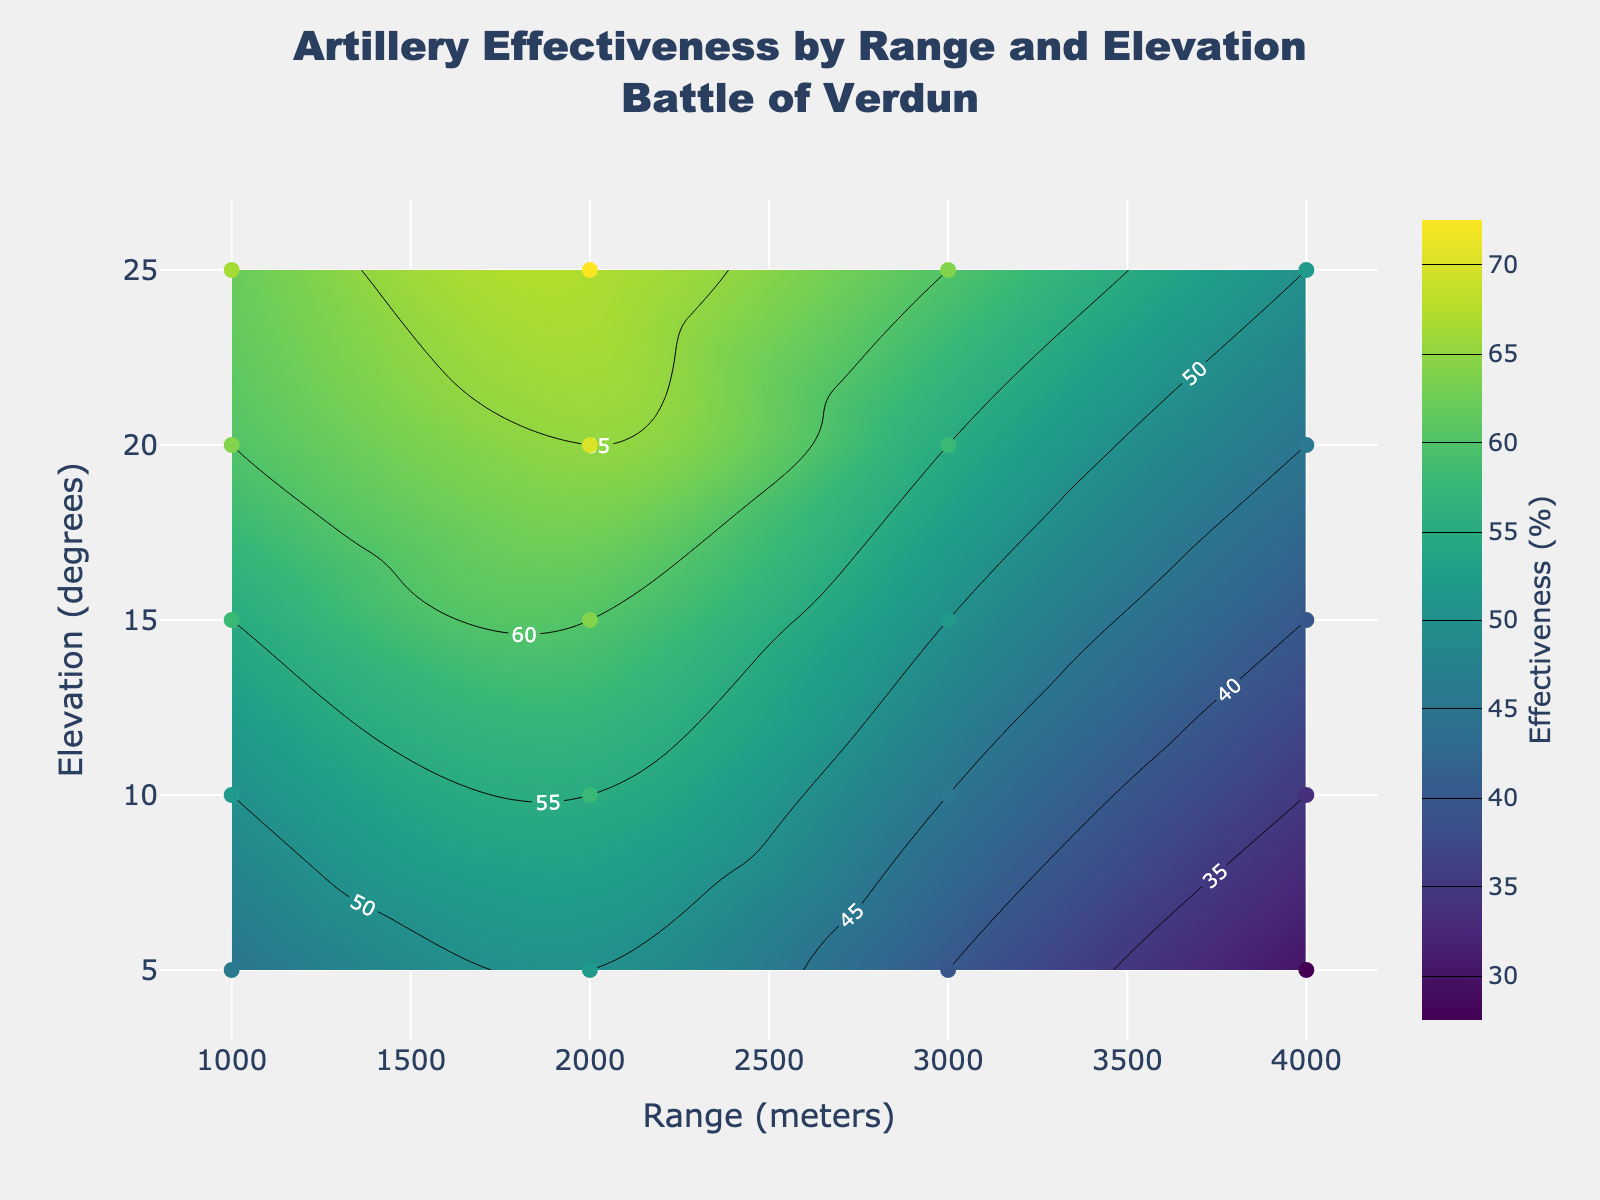What is the title of the plot? The title is displayed at the top of the plot. It reads 'Artillery Effectiveness by Range and Elevation<br>Battle of Verdun'.
Answer: 'Artillery Effectiveness by Range and Elevation<br>Battle of Verdun' What are the ranges of the x-axis and y-axis? The x-axis represents Range (meters) and spans from 800 to 4200 meters. The y-axis represents Elevation (degrees) and spans from 3 to 27 degrees. These ranges are shown on the respective axes.
Answer: Range: 800 to 4200 meters, Elevation: 3 to 27 degrees Which elevation degree shows the highest artillery effectiveness at a range of 2000 meters? To find this, locate the vertical line at 2000 meters on the x-axis and find the peak in effectiveness values along this line. According to the contour plot, the highest effectiveness of 67% occurs at 25 degrees elevation.
Answer: 25 degrees How does artillery effectiveness at 3000 meters compare between 10 degrees and 20 degrees elevation? Find the effectiveness values at the intersection points: at 3000 meters and 10 degrees, effectiveness is 45%; at 3000 meters and 20 degrees, effectiveness is 55%. Comparing, effectiveness is higher at 20 degrees than at 10 degrees.
Answer: Higher at 20 degrees What is the overall trend in artillery effectiveness as the range increases from 1000 meters to 4000 meters at 5 degrees elevation? Follow the horizontal line corresponding to 5 degrees elevation. Effectiveness starts at 45% at 1000 meters, increases to 50% at 2000 meters, then decreases to 40% at 3000 meters and 30% at 4000 meters. The trend shows an initial increase followed by a decrease.
Answer: Initial increase, then decrease At what range and elevation is the artillery effectiveness equal to 60%? Identify the contours labeled with 60%. There are two such points: one at 1000 meters and 15 degrees elevation, and another at 2000 meters and 20 degrees elevation.
Answer: 1000 meters at 15 degrees, 2000 meters at 20 degrees What is the difference in artillery effectiveness between 1000 meters and 4000 meters at 25 degrees elevation? At 25 degrees, effectiveness is: 62% at 1000 meters and 50% at 4000 meters. The difference is calculated as 62% - 50%.
Answer: 12% Is the artillery more effective at 15 degrees elevation or 20 degrees elevation for a range of 3000 meters? Compare the effectiveness values: at 3000 meters and 15 degrees, effectiveness is 50%; at 3000 meters and 20 degrees, effectiveness is 55%. Effectiveness is higher at 20 degrees elevation.
Answer: More effective at 20 degrees What color on the plot represents the highest effectiveness values? Examine the color scale along the contour plot. The highest effectiveness values are represented by the brightest colors at the top of the color scale which is yellow.
Answer: Yellow 